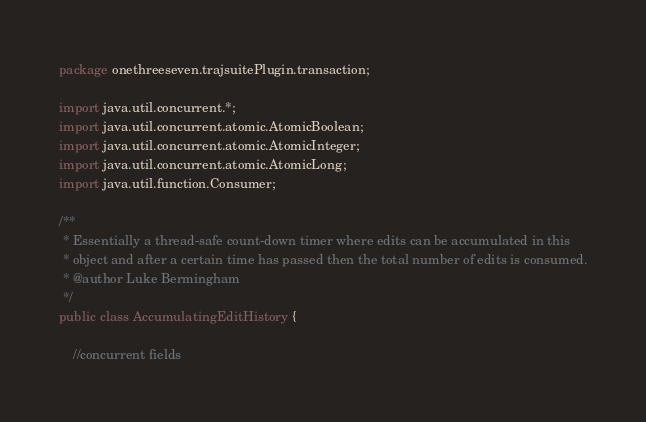Convert code to text. <code><loc_0><loc_0><loc_500><loc_500><_Java_>package onethreeseven.trajsuitePlugin.transaction;

import java.util.concurrent.*;
import java.util.concurrent.atomic.AtomicBoolean;
import java.util.concurrent.atomic.AtomicInteger;
import java.util.concurrent.atomic.AtomicLong;
import java.util.function.Consumer;

/**
 * Essentially a thread-safe count-down timer where edits can be accumulated in this
 * object and after a certain time has passed then the total number of edits is consumed.
 * @author Luke Bermingham
 */
public class AccumulatingEditHistory {

    //concurrent fields</code> 